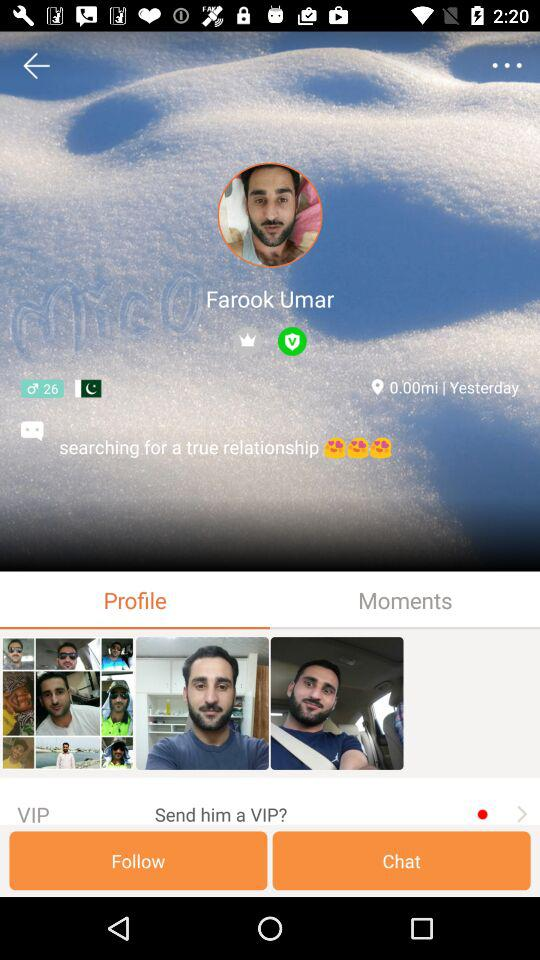Which tab is opened? The opened tab is "Profile". 